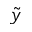Convert formula to latex. <formula><loc_0><loc_0><loc_500><loc_500>\tilde { y }</formula> 